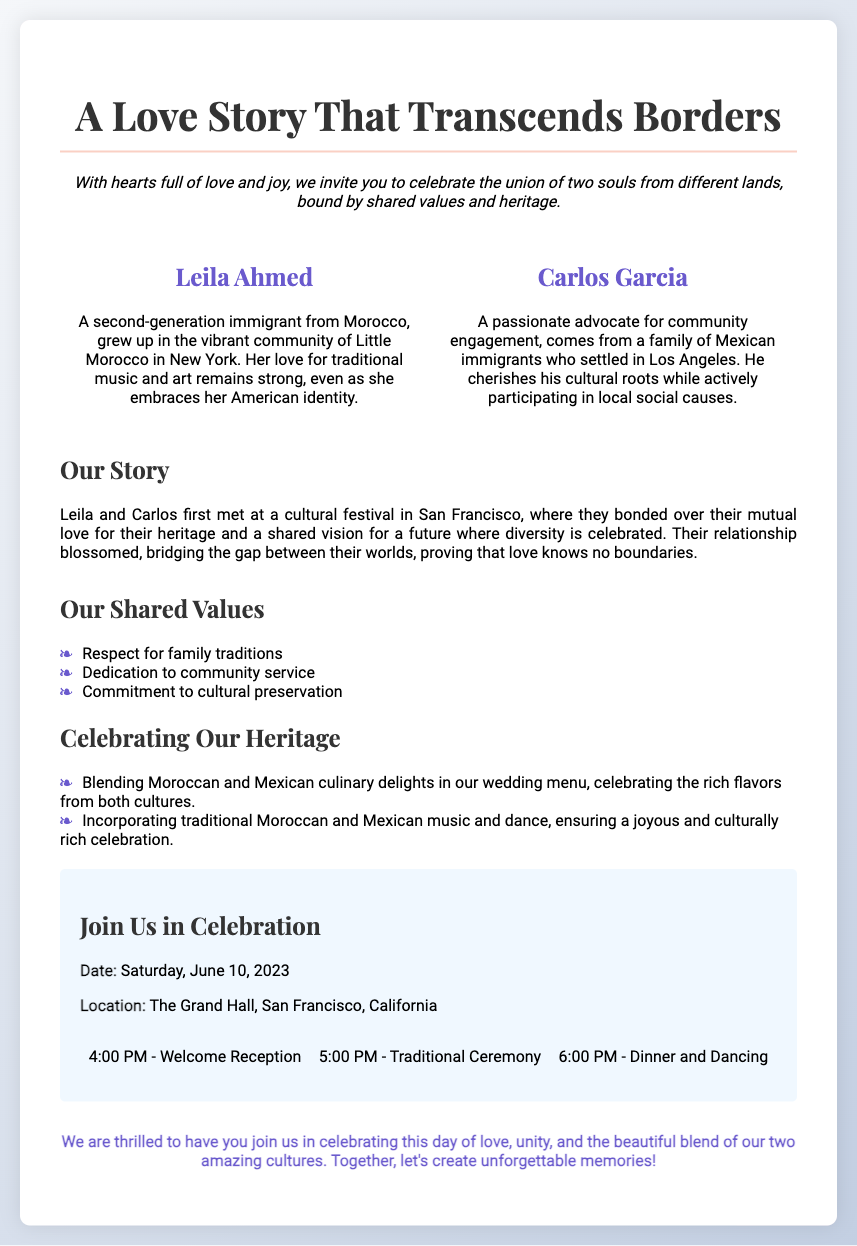What are the names of the couple? The couple's names are presented in the document, which clearly states "Leila Ahmed" and "Carlos Garcia."
Answer: Leila Ahmed and Carlos Garcia When did the wedding take place? The document specifies the wedding date, which is mentioned as "Saturday, June 10, 2023."
Answer: June 10, 2023 Where is the wedding location? The location of the wedding is indicated in the document as "The Grand Hall, San Francisco, California."
Answer: The Grand Hall, San Francisco, California What cultural heritages are celebrated in the wedding? The document highlights the cultural heritages of the couple, specifically mentioning "Moroccan" and "Mexican."
Answer: Moroccan and Mexican What is one of the shared values of the couple? The document lists shared values, one of which is "Respect for family traditions."
Answer: Respect for family traditions How did Leila and Carlos meet? The document describes their meeting as occurring at a cultural festival in San Francisco, providing context to their relationship.
Answer: A cultural festival in San Francisco What time does the welcome reception begin? The starting time for the welcome reception is stated in the document as "4:00 PM."
Answer: 4:00 PM What is a special culinary feature of their wedding menu? The document mentions a specific feature of the wedding menu which includes "Blending Moroccan and Mexican culinary delights."
Answer: Blending Moroccan and Mexican culinary delights 